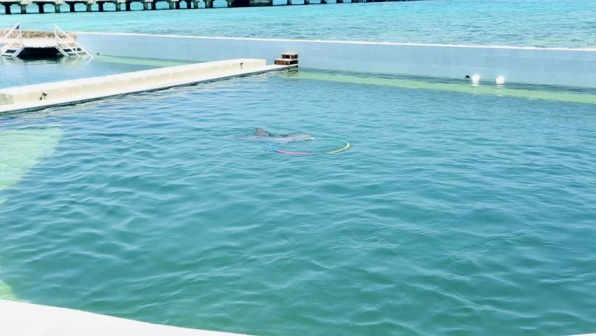Describe the elements found in this image. The image features a serene aquatic environment with a dolphin swimming in a large, clear pool. The pool is surrounded by white and gray concrete walls. In the background, there is a long, brown wooden pier extending into the water, with a small white building with a brown roof at its end. Additionally, two white buoys float near the pier, contrasting with the blue-green water. Can you tell me more about the surroundings and their possible purpose? The surroundings suggest that the dolphin is in a contained, yet spacious environment, likely an aquarium or a research facility. The concrete walls serve to define and secure the area. The brown wooden pier in the background extends from the land into the water, providing access for people to the pool area or for maintenance purposes. The small building located at the end of the pier could function as a watchtower, supply storage, or administrative office for monitoring and caring for the aquatic life. The two white buoys serve as navigational aids or safety markers, indicating safe zones or boundaries within the water. 